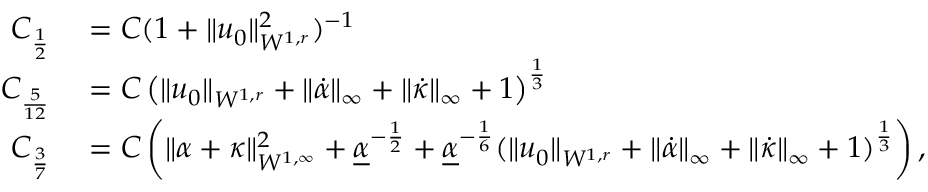<formula> <loc_0><loc_0><loc_500><loc_500>\begin{array} { r l } { C _ { \frac { 1 } { 2 } } } & = C ( 1 + \| u _ { 0 } \| _ { W ^ { 1 , r } } ^ { 2 } ) ^ { - 1 } } \\ { C _ { \frac { 5 } { 1 2 } } } & = C \left ( \| u _ { 0 } \| _ { W ^ { 1 , r } } + \| \dot { \alpha } \| _ { \infty } + \| \dot { \kappa } \| _ { \infty } + 1 \right ) ^ { \frac { 1 } { 3 } } } \\ { C _ { \frac { 3 } { 7 } } } & = C \left ( \| \alpha + \kappa \| _ { W ^ { 1 , \infty } } ^ { 2 } + \underline { \alpha } ^ { - \frac { 1 } { 2 } } + \underline { \alpha } ^ { - \frac { 1 } { 6 } } ( \| u _ { 0 } \| _ { W ^ { 1 , r } } + \| \dot { \alpha } \| _ { \infty } + \| \dot { \kappa } \| _ { \infty } + 1 ) ^ { \frac { 1 } { 3 } } \right ) , } \end{array}</formula> 